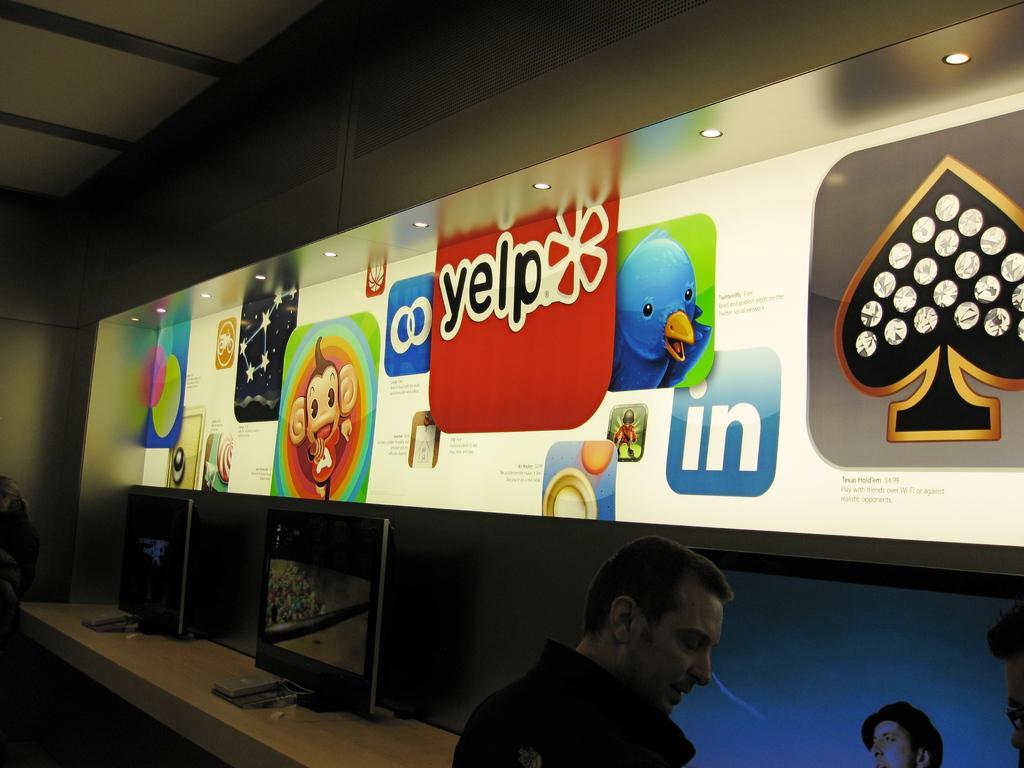How would you summarize this image in a sentence or two? In this picture there is a man who is sitting near to the table. On the table I can see the computer screen. In the center I can see the posts which are placed near to the wall. On the left I can see another person who is standing near to the wall. 